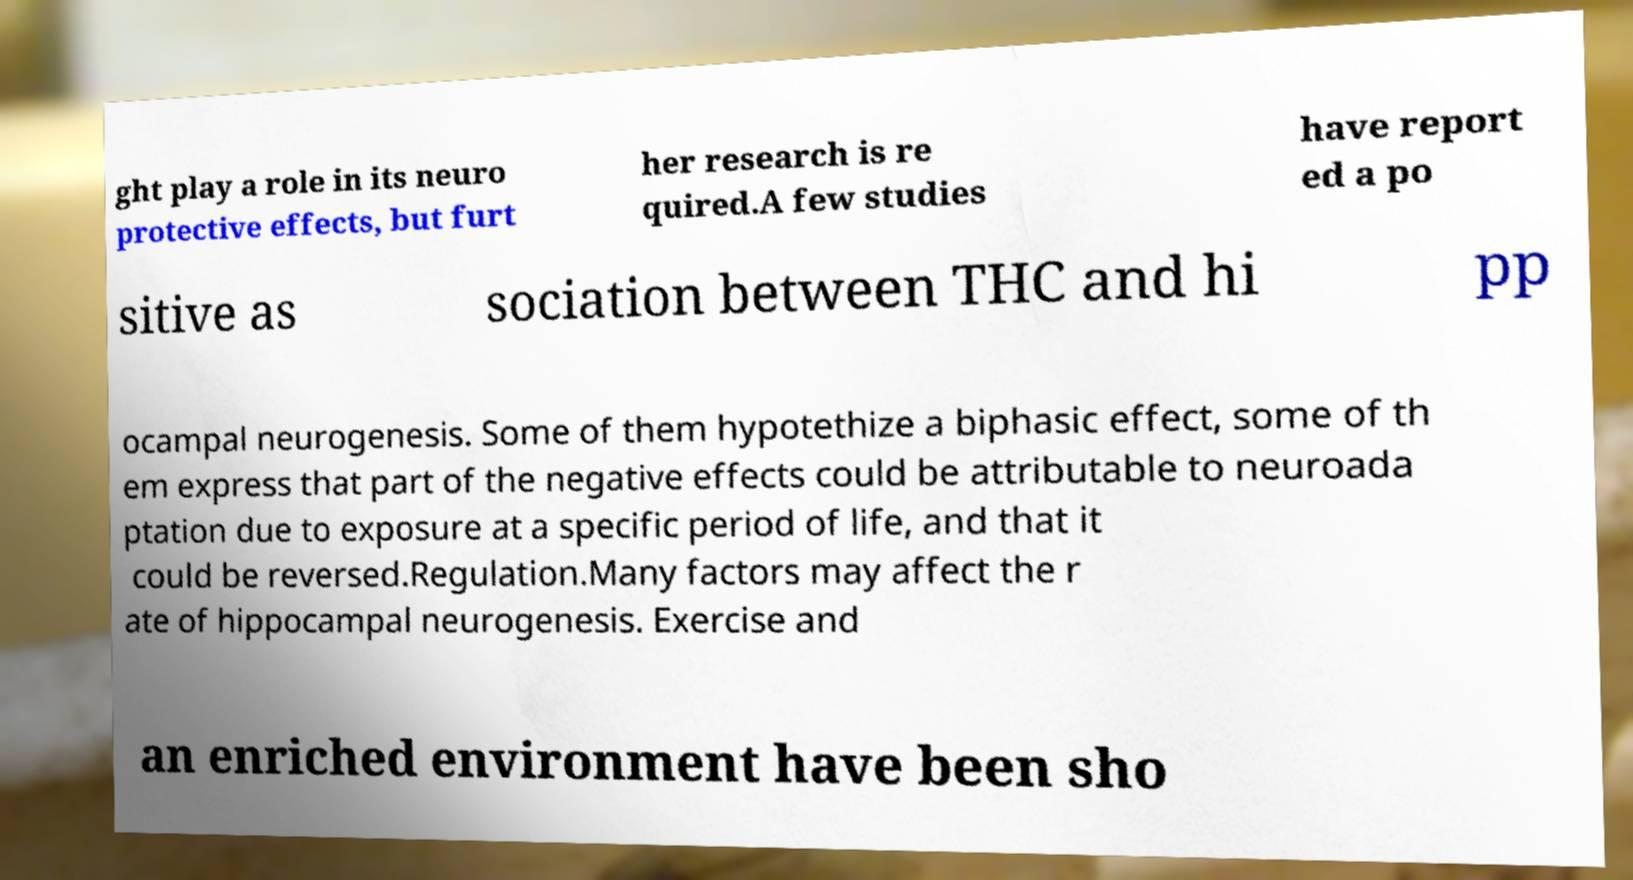I need the written content from this picture converted into text. Can you do that? ght play a role in its neuro protective effects, but furt her research is re quired.A few studies have report ed a po sitive as sociation between THC and hi pp ocampal neurogenesis. Some of them hypotethize a biphasic effect, some of th em express that part of the negative effects could be attributable to neuroada ptation due to exposure at a specific period of life, and that it could be reversed.Regulation.Many factors may affect the r ate of hippocampal neurogenesis. Exercise and an enriched environment have been sho 